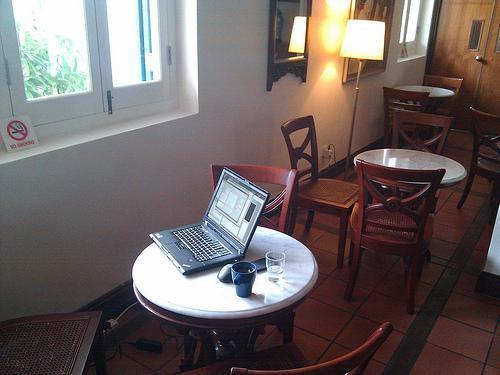How many laptops are there?
Give a very brief answer. 1. 